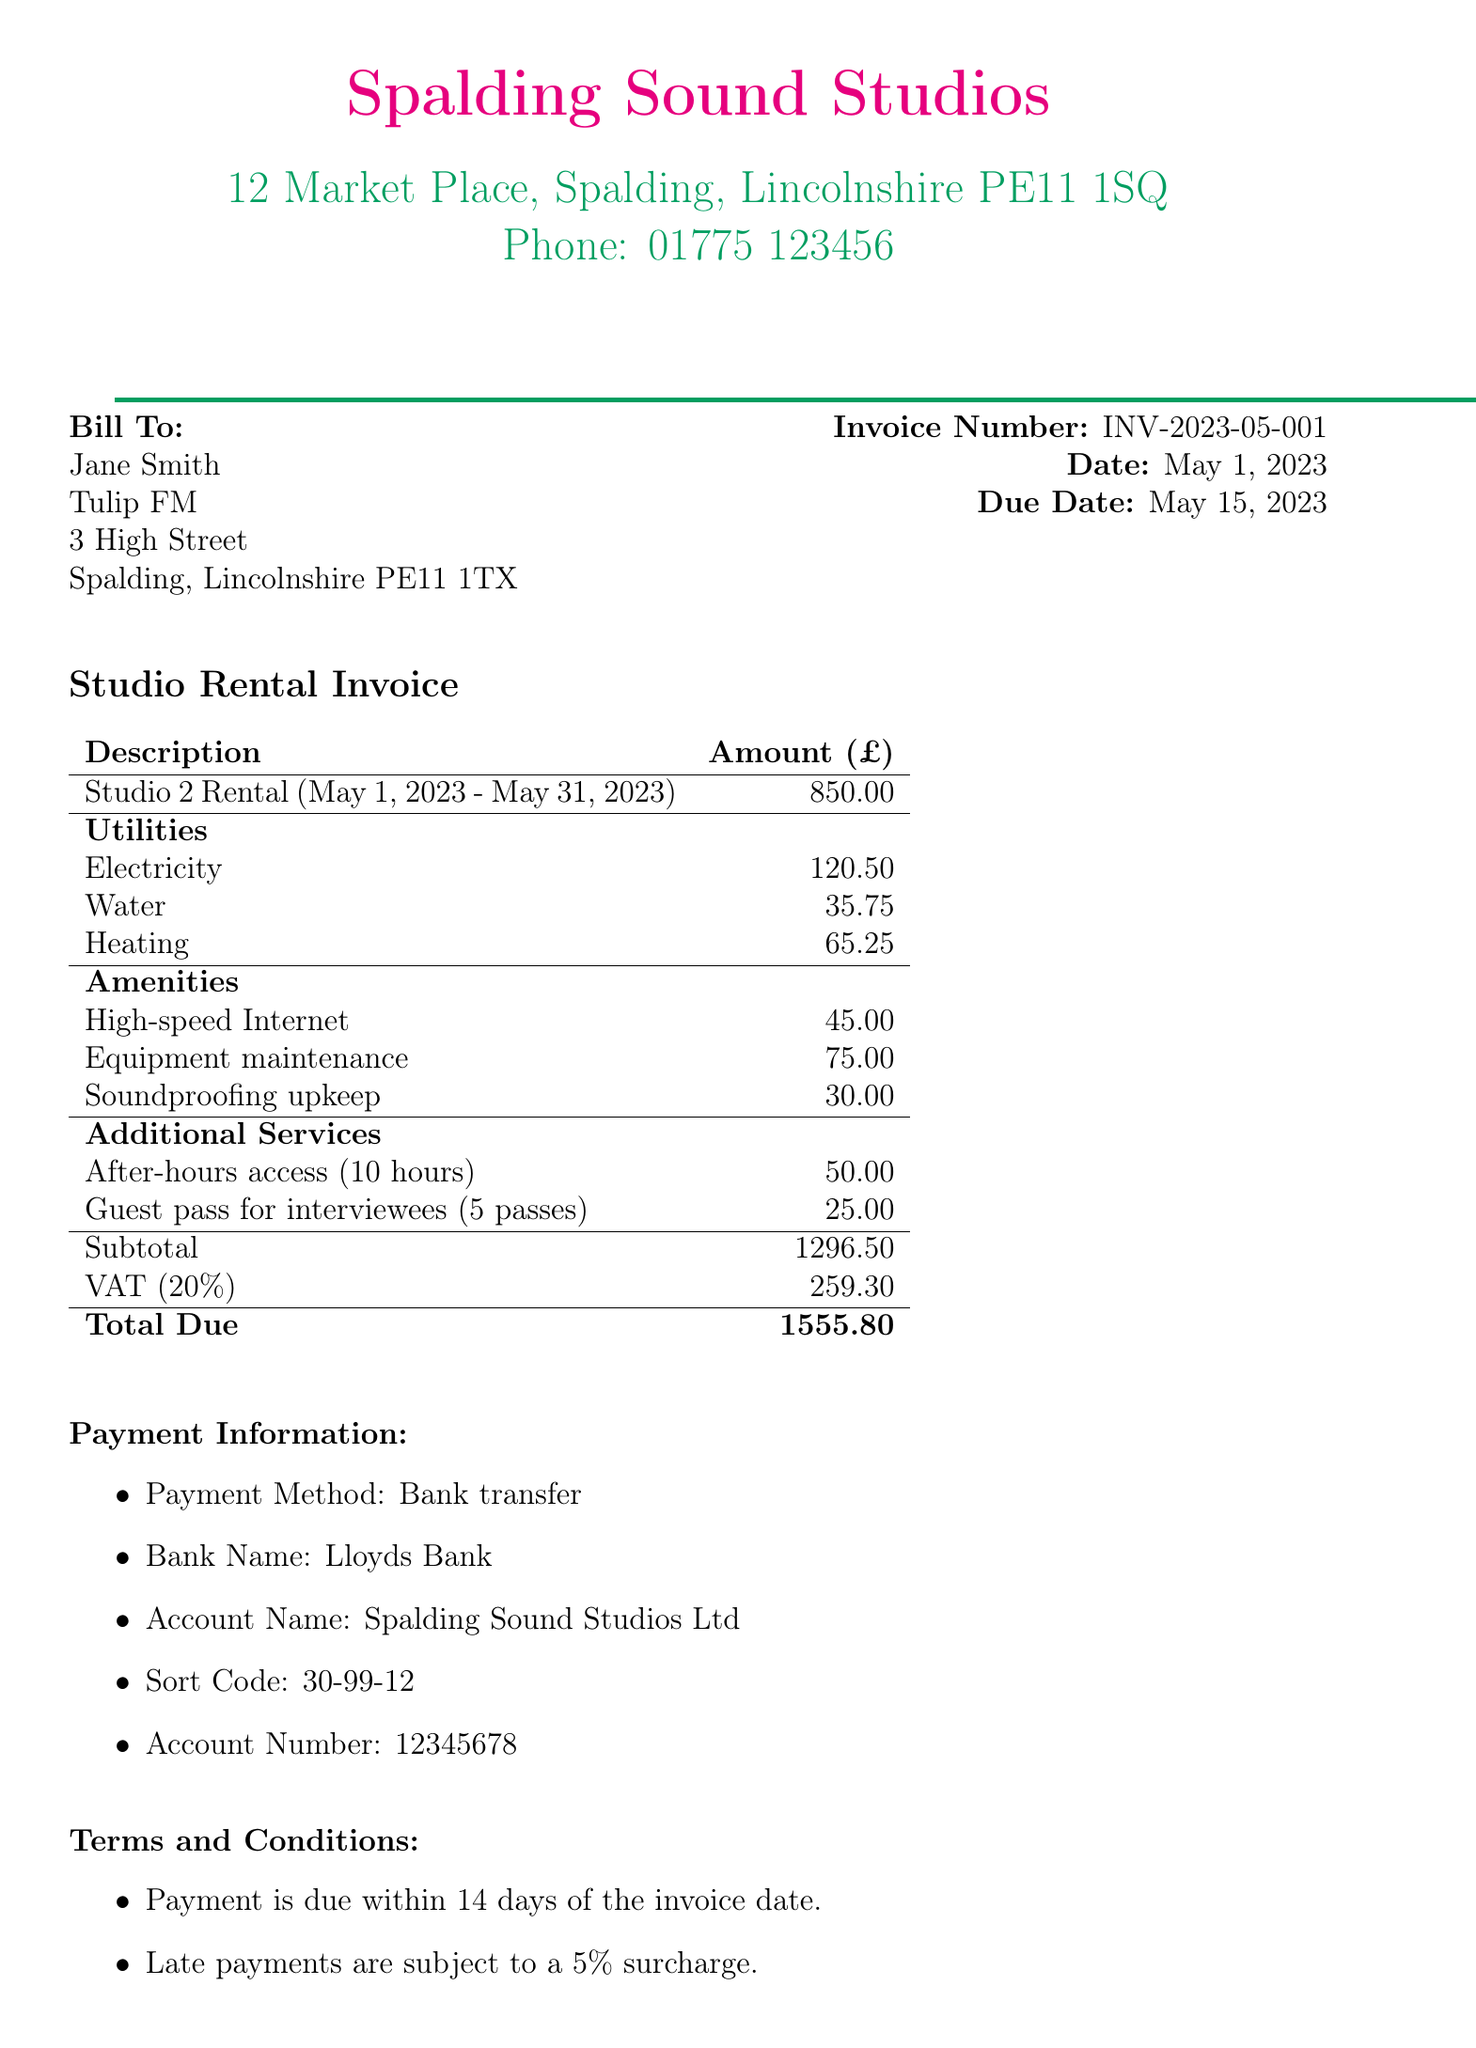What is the invoice number? The invoice number is a unique identifier for this transaction, which is listed in the document.
Answer: INV-2023-05-001 Who is the client? The client's name appears under the Bill To section of the invoice.
Answer: Jane Smith What is the rental period? The rental period indicates the duration for which the studio is rented, as described in the rental details.
Answer: May 1, 2023 - May 31, 2023 What is the total due amount? The total due is the final amount payable, calculated at the end of the invoice.
Answer: 1555.80 How much is the VAT amount? The VAT amount is mentioned under payment information and indicates the tax applied to the subtotal.
Answer: 259.30 What is the payment method? The payment method specifies how the payment should be made according to the invoice details.
Answer: Bank transfer What is included in the utilities breakdown? This question requires understanding the different charges listed under utilities in the document.
Answer: Electricity, Water, Heating What is the base rent for the studio? The base rent is the initial rental amount listed before utilities and other charges.
Answer: 850.00 What is the due date for payment? The due date informs the client of the deadline for settling the invoice.
Answer: May 15, 2023 